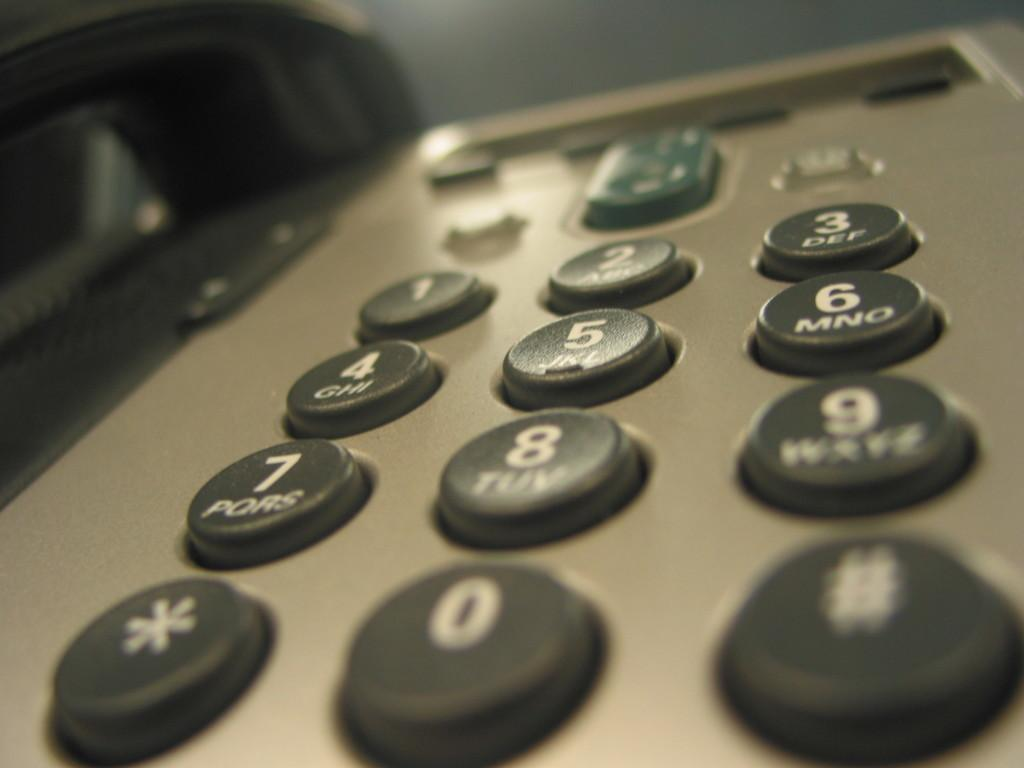<image>
Offer a succinct explanation of the picture presented. Telephone with a button that says PQRS on it. 